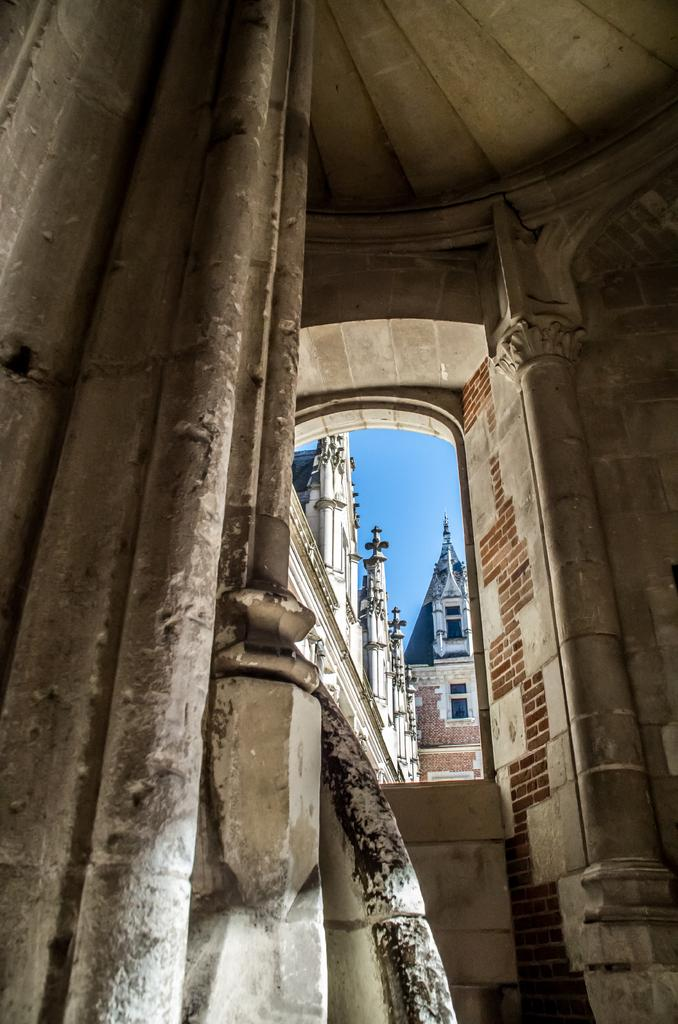Where was the image taken? The image was taken inside a room. What can be seen on the left side of the room? There are walls on the left side of the room. What feature is present in the center of the room? There is a window in the center of the room. What can be seen outside the window? Buildings and the sky are visible outside the window. What type of respect can be seen being given to the monkey in the image? There is no monkey present in the image, so it is not possible to determine if any respect is being given. 